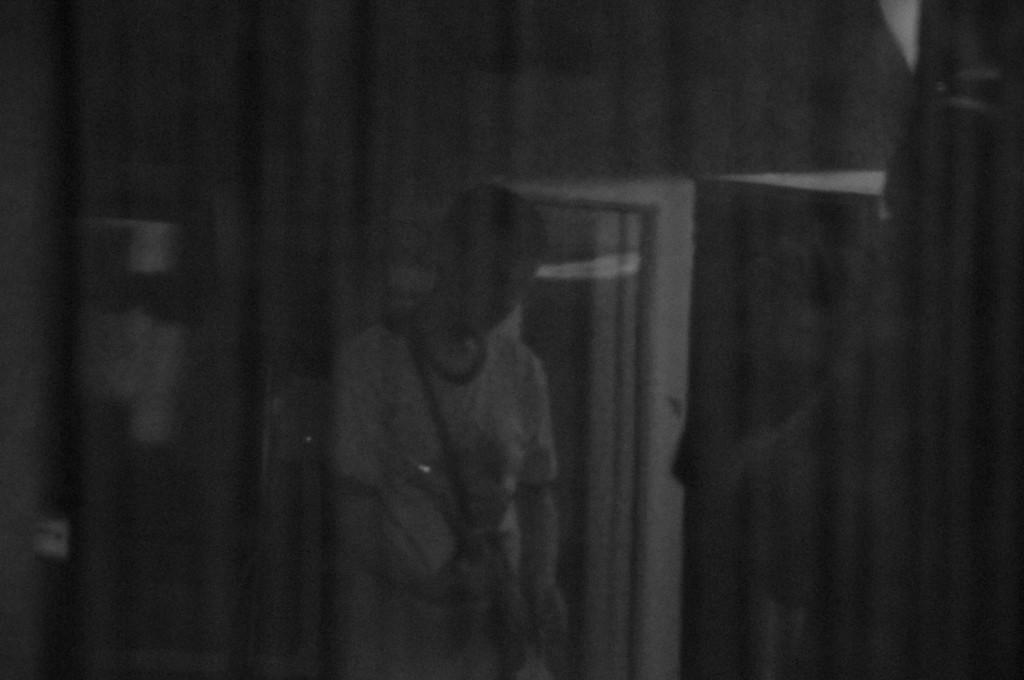What is the main subject of the image? There is a person standing in the image. What can be seen in the background of the image? There is a wall in the background of the image. How would you describe the quality of the image? The image is blurred. What type of machine is being used by the person in the image? There is no machine visible in the image; it only features a person standing in front of a wall. 